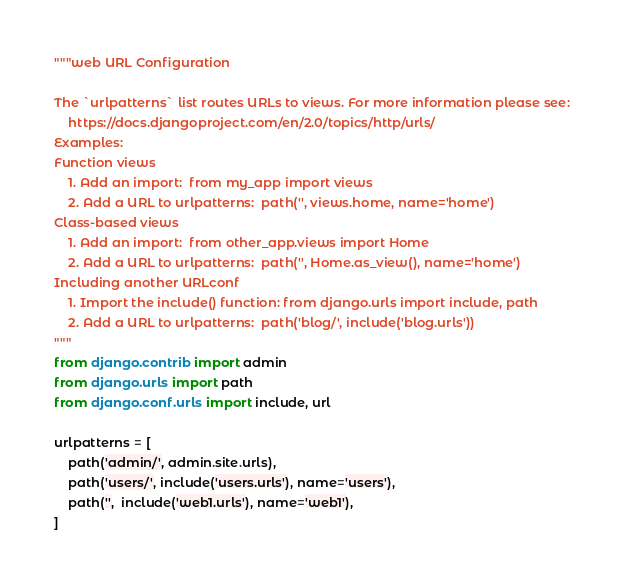<code> <loc_0><loc_0><loc_500><loc_500><_Python_>"""web URL Configuration

The `urlpatterns` list routes URLs to views. For more information please see:
    https://docs.djangoproject.com/en/2.0/topics/http/urls/
Examples:
Function views
    1. Add an import:  from my_app import views
    2. Add a URL to urlpatterns:  path('', views.home, name='home')
Class-based views
    1. Add an import:  from other_app.views import Home
    2. Add a URL to urlpatterns:  path('', Home.as_view(), name='home')
Including another URLconf
    1. Import the include() function: from django.urls import include, path
    2. Add a URL to urlpatterns:  path('blog/', include('blog.urls'))
"""
from django.contrib import admin
from django.urls import path
from django.conf.urls import include, url

urlpatterns = [
    path('admin/', admin.site.urls),
    path('users/', include('users.urls'), name='users'),
    path('',  include('web1.urls'), name='web1'),
]
</code> 